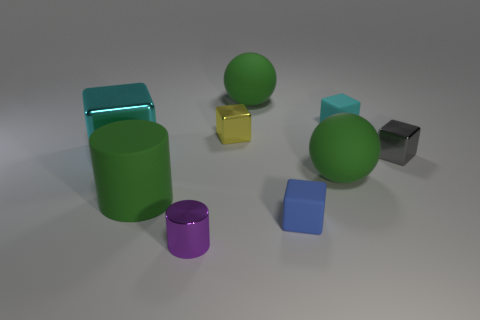What size is the yellow block that is made of the same material as the big cyan block?
Your response must be concise. Small. How many balls are either tiny cyan matte things or purple metal things?
Offer a terse response. 0. Is the number of cyan shiny cylinders greater than the number of purple cylinders?
Make the answer very short. No. How many blue blocks are the same size as the purple metal object?
Provide a succinct answer. 1. There is a matte object that is the same color as the large metal block; what shape is it?
Keep it short and to the point. Cube. What number of things are either small cubes right of the blue thing or big rubber balls?
Give a very brief answer. 4. Are there fewer red metallic spheres than large spheres?
Ensure brevity in your answer.  Yes. The tiny gray thing that is the same material as the tiny cylinder is what shape?
Offer a terse response. Cube. Are there any tiny yellow metallic objects in front of the gray cube?
Give a very brief answer. No. Are there fewer large cyan cubes behind the large cyan metallic thing than large objects?
Make the answer very short. Yes. 